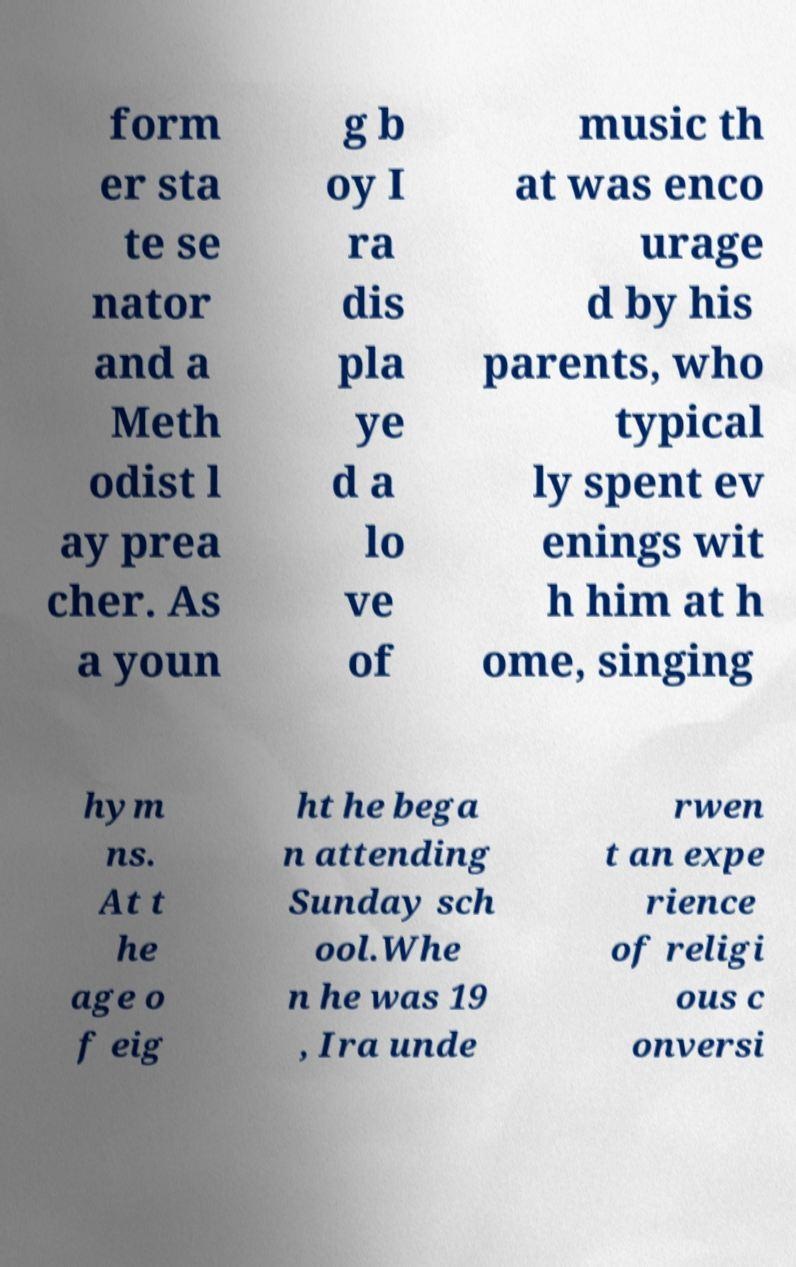Can you accurately transcribe the text from the provided image for me? form er sta te se nator and a Meth odist l ay prea cher. As a youn g b oy I ra dis pla ye d a lo ve of music th at was enco urage d by his parents, who typical ly spent ev enings wit h him at h ome, singing hym ns. At t he age o f eig ht he bega n attending Sunday sch ool.Whe n he was 19 , Ira unde rwen t an expe rience of religi ous c onversi 